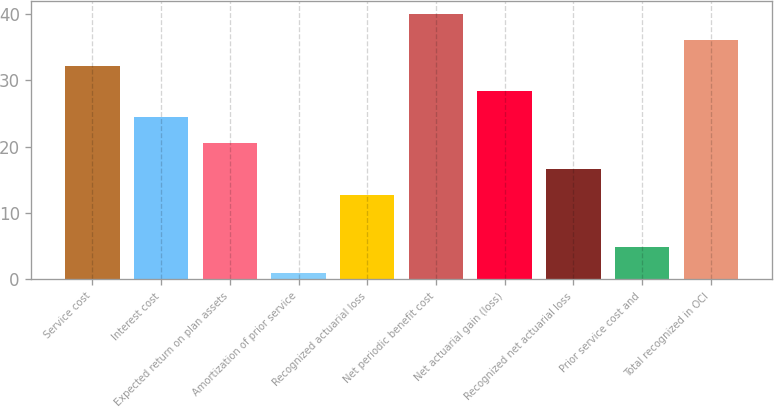Convert chart. <chart><loc_0><loc_0><loc_500><loc_500><bar_chart><fcel>Service cost<fcel>Interest cost<fcel>Expected return on plan assets<fcel>Amortization of prior service<fcel>Recognized actuarial loss<fcel>Net periodic benefit cost<fcel>Net actuarial gain (loss)<fcel>Recognized net actuarial loss<fcel>Prior service cost and<fcel>Total recognized in OCI<nl><fcel>32.2<fcel>24.4<fcel>20.5<fcel>1<fcel>12.7<fcel>40<fcel>28.3<fcel>16.6<fcel>4.9<fcel>36.1<nl></chart> 